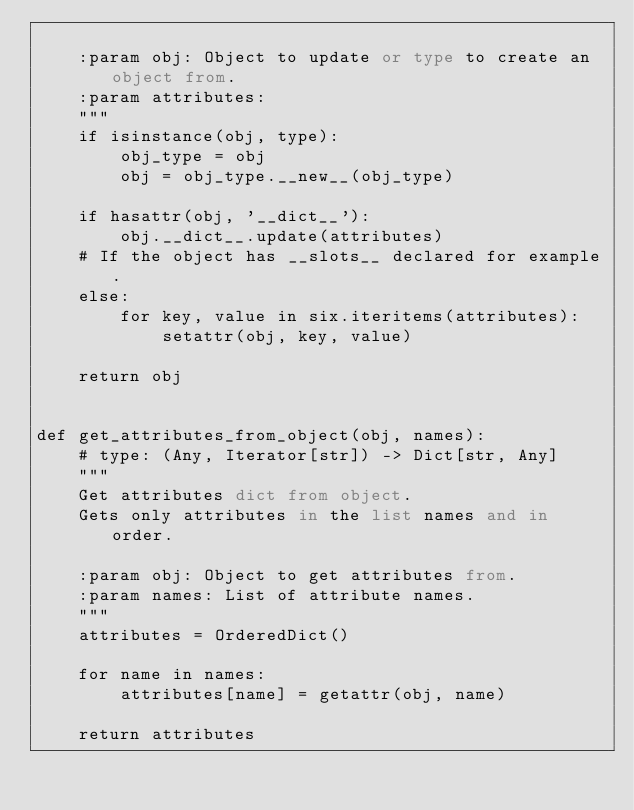<code> <loc_0><loc_0><loc_500><loc_500><_Python_>
    :param obj: Object to update or type to create an object from.
    :param attributes:
    """
    if isinstance(obj, type):
        obj_type = obj
        obj = obj_type.__new__(obj_type)

    if hasattr(obj, '__dict__'):
        obj.__dict__.update(attributes)
    # If the object has __slots__ declared for example.
    else:
        for key, value in six.iteritems(attributes):
            setattr(obj, key, value)

    return obj


def get_attributes_from_object(obj, names):
    # type: (Any, Iterator[str]) -> Dict[str, Any]
    """
    Get attributes dict from object.
    Gets only attributes in the list names and in order.

    :param obj: Object to get attributes from.
    :param names: List of attribute names.
    """
    attributes = OrderedDict()

    for name in names:
        attributes[name] = getattr(obj, name)

    return attributes
</code> 